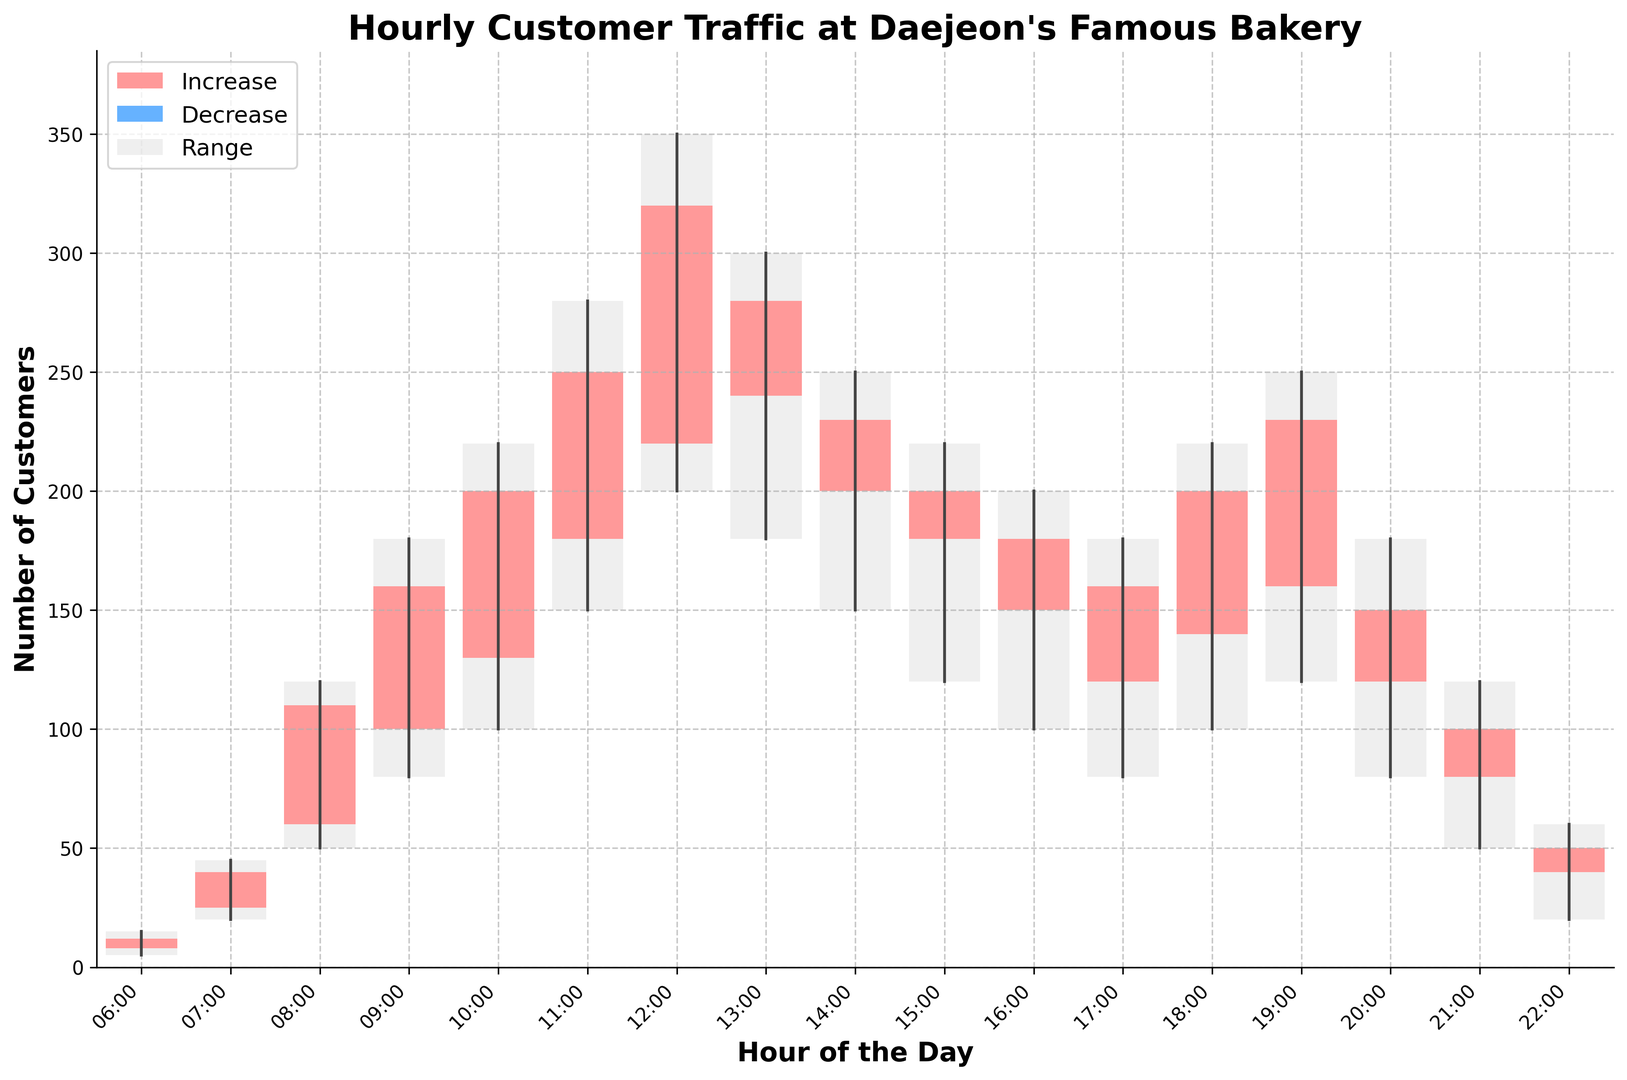What hour has the highest maximum customer count? The chart shows hourly customer counts; the highest maximum value is at 12 PM where the top of the range peaks.
Answer: 12 PM During which hour does the minimum customer count exceed 100? The chart displays the minimum customer counts for each hour; at 11 AM, the minimum count surpasses 100.
Answer: 11 AM How many hours have an increase in customer count from open to close? Identify the bars where the closing count is higher (red bars). Count these occurrences: hours 6, 7, 8, 9, 10, 11, 12, 14, 16, 18, and 19.
Answer: 11 hours Which hour had the biggest difference between the maximum and the minimum customer count? Check the range (difference between maximum and minimum) represented by the gray bars. The hour with the largest range is at 12 PM.
Answer: 12 PM What is the average closing customer count from 6 AM to 8 AM? Sum the closing customer counts for 6 AM, 7 AM, and 8 AM (12, 40, 110) and divide by 3. (12 + 40 + 110) / 3 = 162 / 3
Answer: 54 Which hour experiences the steepest decline in customer count from start to close? Identify bars where the color indicates blue and the difference between open and close is largest. This occurs at 13:00.
Answer: 13 PM During which hour does the closing customer count peak? Observe the closing counts and identify the highest value. The highest closing count is at 12 PM.
Answer: 12 PM Which hour saw a drop in customer count but still had a relatively high maximum count? Look for hours with blue bars (indicating a drop), with a high maximum count. At 1 PM, the count drops from 240 to 280, but it still has a high maximum count of 300.
Answer: 1 PM (13:00) What hour shows the lowest minimum customer count during the evening (6 PM to 10 PM)? From 6 PM to 10 PM, observe the minimum values; the smallest value is at 10 PM where the minimum is 20.
Answer: 22:00 What is the total range of customer counts between the hours of 16:00 and 18:00? Calculate the range for each hour and sum them. For 16:00 (200 - 100 = 100), 17:00 (180 - 80 = 100), 18:00 (200 - 100 = 100). Total = 100 + 100 + 100 = 300.
Answer: 300 